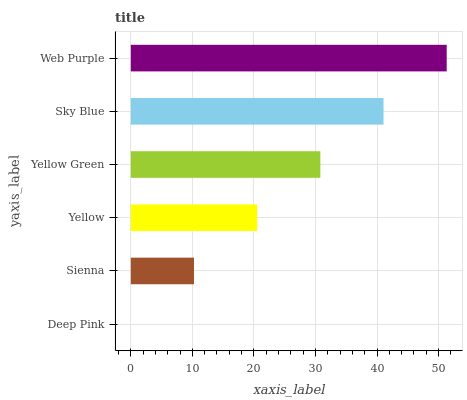Is Deep Pink the minimum?
Answer yes or no. Yes. Is Web Purple the maximum?
Answer yes or no. Yes. Is Sienna the minimum?
Answer yes or no. No. Is Sienna the maximum?
Answer yes or no. No. Is Sienna greater than Deep Pink?
Answer yes or no. Yes. Is Deep Pink less than Sienna?
Answer yes or no. Yes. Is Deep Pink greater than Sienna?
Answer yes or no. No. Is Sienna less than Deep Pink?
Answer yes or no. No. Is Yellow Green the high median?
Answer yes or no. Yes. Is Yellow the low median?
Answer yes or no. Yes. Is Web Purple the high median?
Answer yes or no. No. Is Deep Pink the low median?
Answer yes or no. No. 